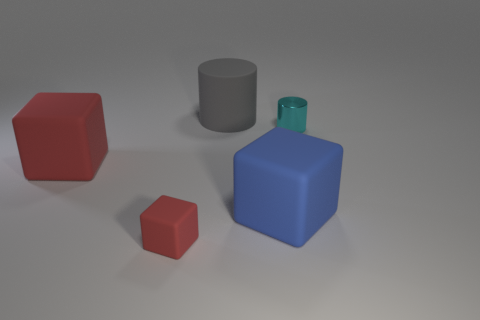Are there any rubber things right of the gray matte object?
Provide a short and direct response. Yes. Is the size of the blue rubber cube to the right of the large gray object the same as the red block in front of the blue matte cube?
Provide a short and direct response. No. Is there another gray metallic thing that has the same size as the metal object?
Your answer should be very brief. No. There is a large rubber object that is left of the tiny red thing; does it have the same shape as the small cyan object?
Keep it short and to the point. No. What is the red thing that is in front of the big blue cube made of?
Your answer should be very brief. Rubber. There is a large matte thing that is behind the small object to the right of the large cylinder; what is its shape?
Offer a very short reply. Cylinder. There is a cyan shiny object; does it have the same shape as the small thing that is in front of the blue rubber block?
Give a very brief answer. No. What number of shiny cylinders are on the right side of the cyan cylinder that is right of the blue block?
Provide a succinct answer. 0. What is the material of the small thing that is the same shape as the large gray rubber object?
Keep it short and to the point. Metal. What number of blue objects are either rubber blocks or large rubber blocks?
Offer a terse response. 1. 